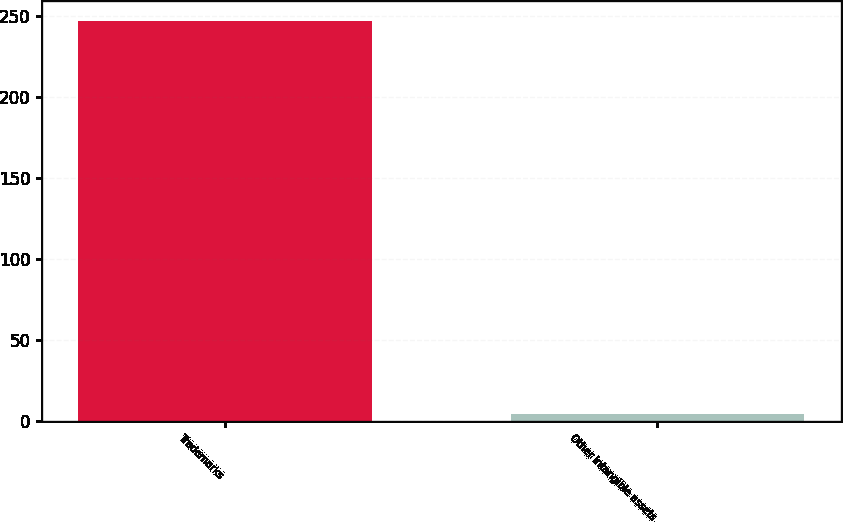Convert chart. <chart><loc_0><loc_0><loc_500><loc_500><bar_chart><fcel>Trademarks<fcel>Other intangible assets<nl><fcel>247<fcel>4<nl></chart> 